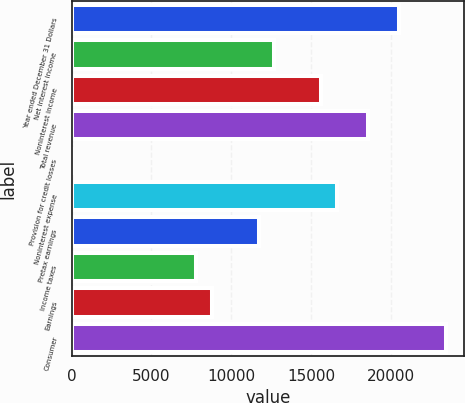<chart> <loc_0><loc_0><loc_500><loc_500><bar_chart><fcel>Year ended December 31 Dollars<fcel>Net interest income<fcel>Noninterest income<fcel>Total revenue<fcel>Provision for credit losses<fcel>Noninterest expense<fcel>Pretax earnings<fcel>Income taxes<fcel>Earnings<fcel>Consumer<nl><fcel>20513.8<fcel>12699.4<fcel>15629.8<fcel>18560.2<fcel>1<fcel>16606.6<fcel>11722.6<fcel>7815.4<fcel>8792.2<fcel>23444.2<nl></chart> 